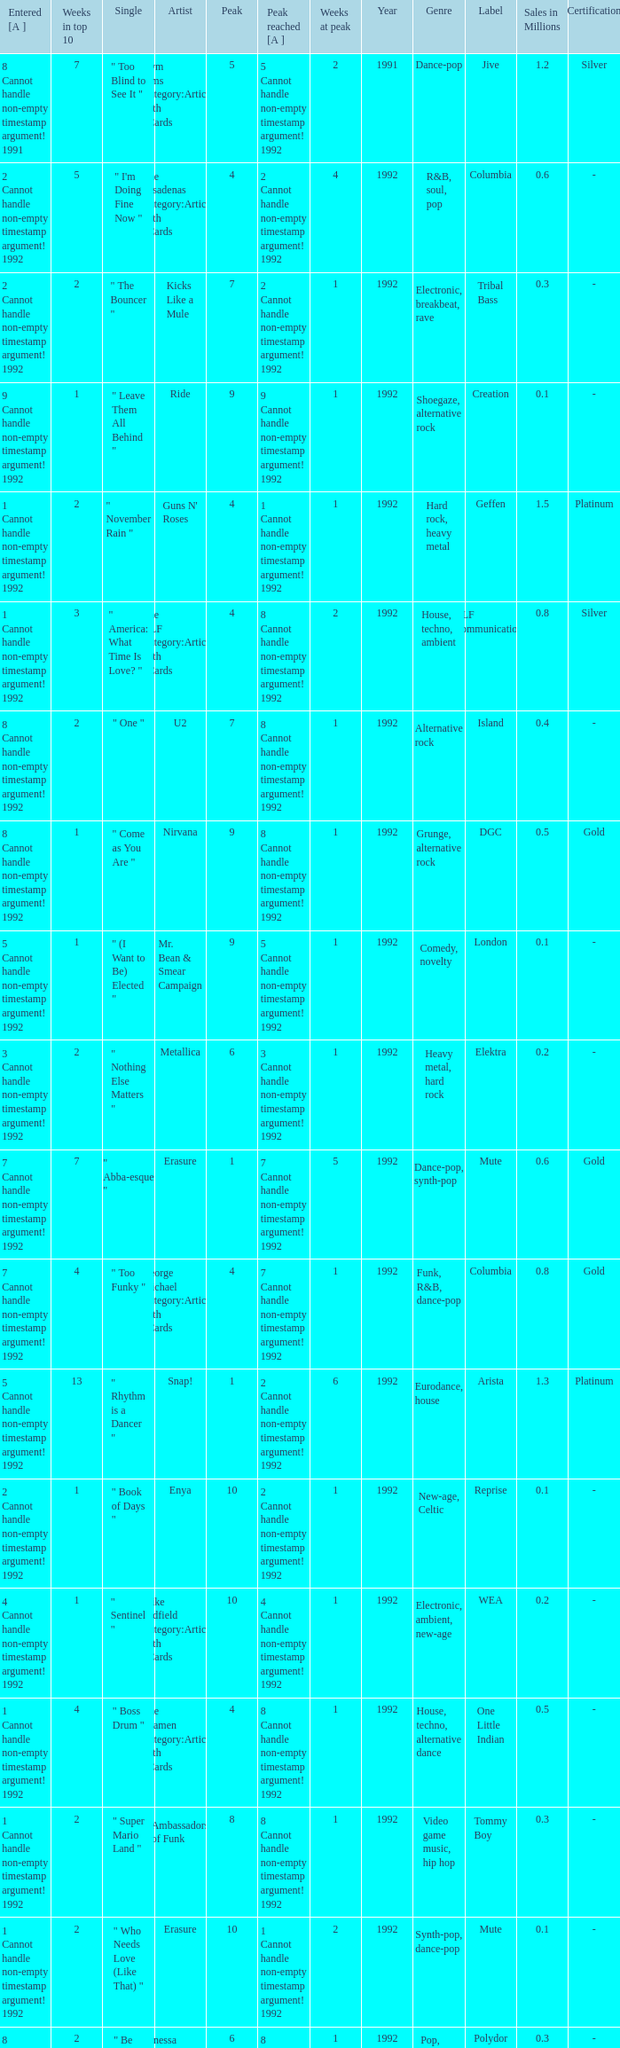If the peak is 9, how many weeks was it in the top 10? 1.0. 